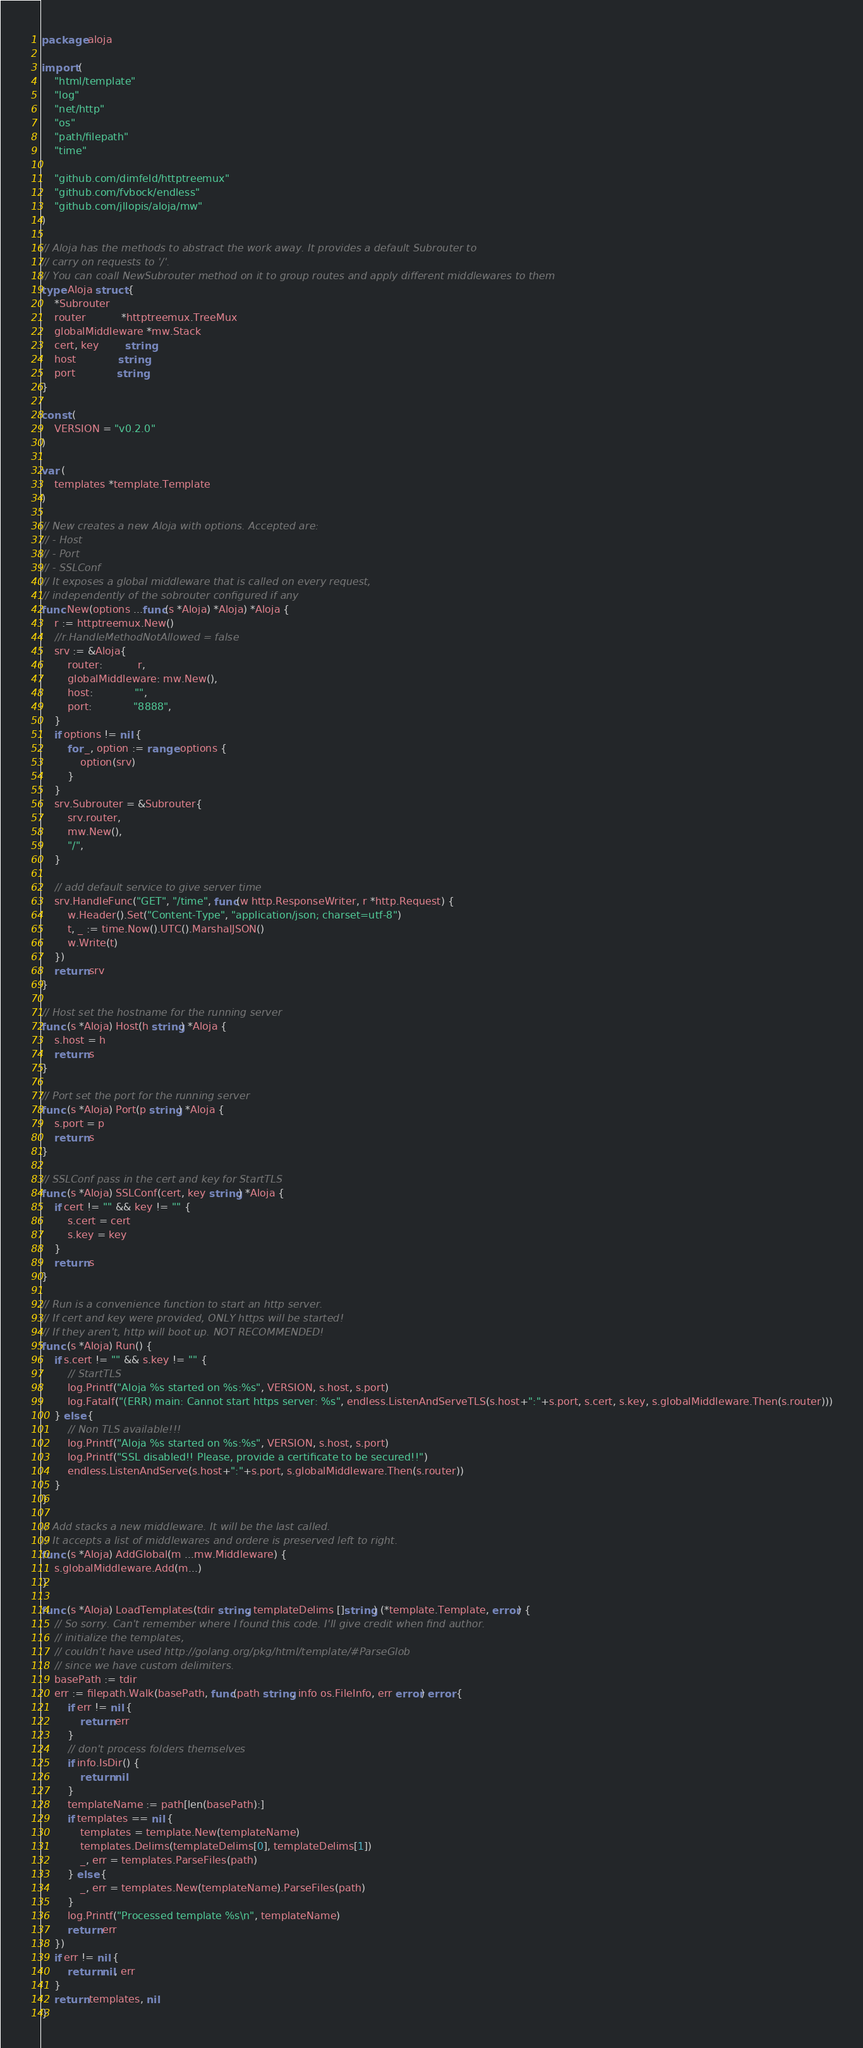Convert code to text. <code><loc_0><loc_0><loc_500><loc_500><_Go_>package aloja

import (
	"html/template"
	"log"
	"net/http"
	"os"
	"path/filepath"
	"time"

	"github.com/dimfeld/httptreemux"
	"github.com/fvbock/endless"
	"github.com/jllopis/aloja/mw"
)

// Aloja has the methods to abstract the work away. It provides a default Subrouter to
// carry on requests to '/'.
// You can coall NewSubrouter method on it to group routes and apply different middlewares to them
type Aloja struct {
	*Subrouter
	router           *httptreemux.TreeMux
	globalMiddleware *mw.Stack
	cert, key        string
	host             string
	port             string
}

const (
	VERSION = "v0.2.0"
)

var (
	templates *template.Template
)

// New creates a new Aloja with options. Accepted are:
// - Host
// - Port
// - SSLConf
// It exposes a global middleware that is called on every request,
// independently of the sobrouter configured if any
func New(options ...func(s *Aloja) *Aloja) *Aloja {
	r := httptreemux.New()
	//r.HandleMethodNotAllowed = false
	srv := &Aloja{
		router:           r,
		globalMiddleware: mw.New(),
		host:             "",
		port:             "8888",
	}
	if options != nil {
		for _, option := range options {
			option(srv)
		}
	}
	srv.Subrouter = &Subrouter{
		srv.router,
		mw.New(),
		"/",
	}

	// add default service to give server time
	srv.HandleFunc("GET", "/time", func(w http.ResponseWriter, r *http.Request) {
		w.Header().Set("Content-Type", "application/json; charset=utf-8")
		t, _ := time.Now().UTC().MarshalJSON()
		w.Write(t)
	})
	return srv
}

// Host set the hostname for the running server
func (s *Aloja) Host(h string) *Aloja {
	s.host = h
	return s
}

// Port set the port for the running server
func (s *Aloja) Port(p string) *Aloja {
	s.port = p
	return s
}

// SSLConf pass in the cert and key for StartTLS
func (s *Aloja) SSLConf(cert, key string) *Aloja {
	if cert != "" && key != "" {
		s.cert = cert
		s.key = key
	}
	return s
}

// Run is a convenience function to start an http server.
// If cert and key were provided, ONLY https will be started!
// If they aren't, http will boot up. NOT RECOMMENDED!
func (s *Aloja) Run() {
	if s.cert != "" && s.key != "" {
		// StartTLS
		log.Printf("Aloja %s started on %s:%s", VERSION, s.host, s.port)
		log.Fatalf("(ERR) main: Cannot start https server: %s", endless.ListenAndServeTLS(s.host+":"+s.port, s.cert, s.key, s.globalMiddleware.Then(s.router)))
	} else {
		// Non TLS available!!!
		log.Printf("Aloja %s started on %s:%s", VERSION, s.host, s.port)
		log.Printf("SSL disabled!! Please, provide a certificate to be secured!!")
		endless.ListenAndServe(s.host+":"+s.port, s.globalMiddleware.Then(s.router))
	}
}

// Add stacks a new middleware. It will be the last called.
// It accepts a list of middlewares and ordere is preserved left to right.
func (s *Aloja) AddGlobal(m ...mw.Middleware) {
	s.globalMiddleware.Add(m...)
}

func (s *Aloja) LoadTemplates(tdir string, templateDelims []string) (*template.Template, error) {
	// So sorry. Can't remember where I found this code. I'll give credit when find author.
	// initialize the templates,
	// couldn't have used http://golang.org/pkg/html/template/#ParseGlob
	// since we have custom delimiters.
	basePath := tdir
	err := filepath.Walk(basePath, func(path string, info os.FileInfo, err error) error {
		if err != nil {
			return err
		}
		// don't process folders themselves
		if info.IsDir() {
			return nil
		}
		templateName := path[len(basePath):]
		if templates == nil {
			templates = template.New(templateName)
			templates.Delims(templateDelims[0], templateDelims[1])
			_, err = templates.ParseFiles(path)
		} else {
			_, err = templates.New(templateName).ParseFiles(path)
		}
		log.Printf("Processed template %s\n", templateName)
		return err
	})
	if err != nil {
		return nil, err
	}
	return templates, nil
}
</code> 